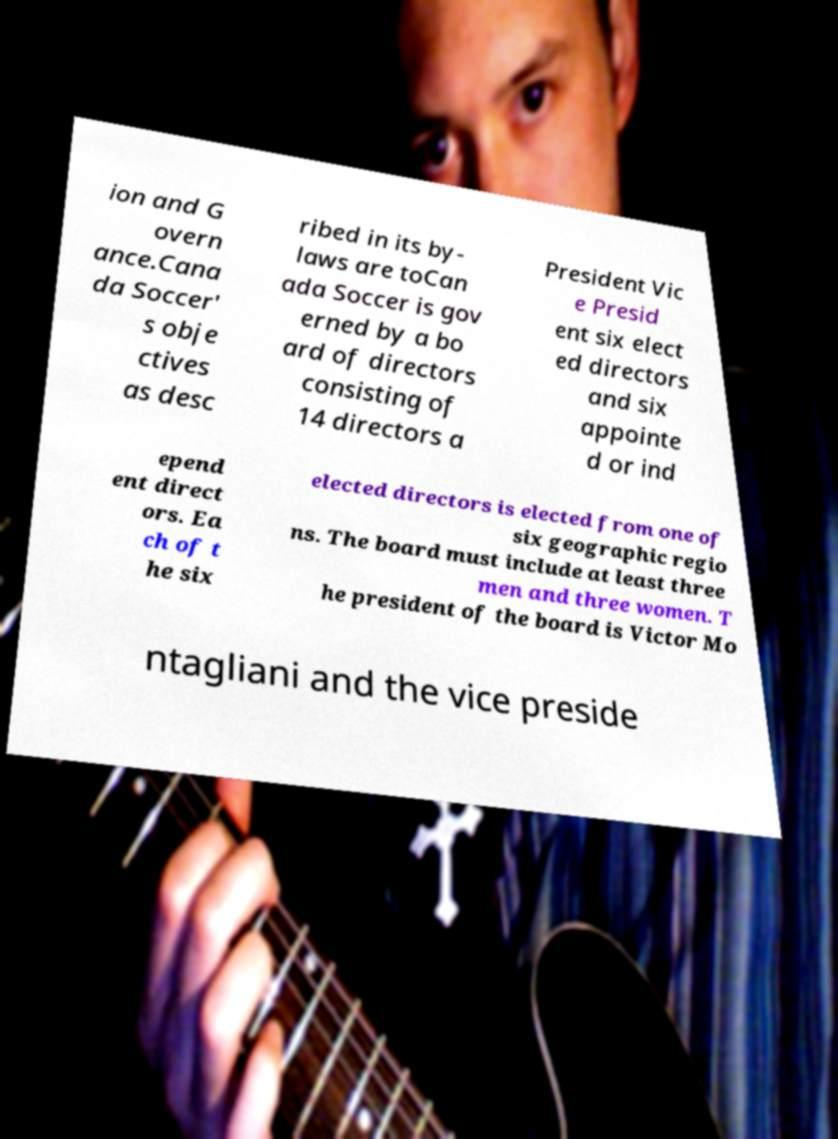There's text embedded in this image that I need extracted. Can you transcribe it verbatim? ion and G overn ance.Cana da Soccer' s obje ctives as desc ribed in its by- laws are toCan ada Soccer is gov erned by a bo ard of directors consisting of 14 directors a President Vic e Presid ent six elect ed directors and six appointe d or ind epend ent direct ors. Ea ch of t he six elected directors is elected from one of six geographic regio ns. The board must include at least three men and three women. T he president of the board is Victor Mo ntagliani and the vice preside 